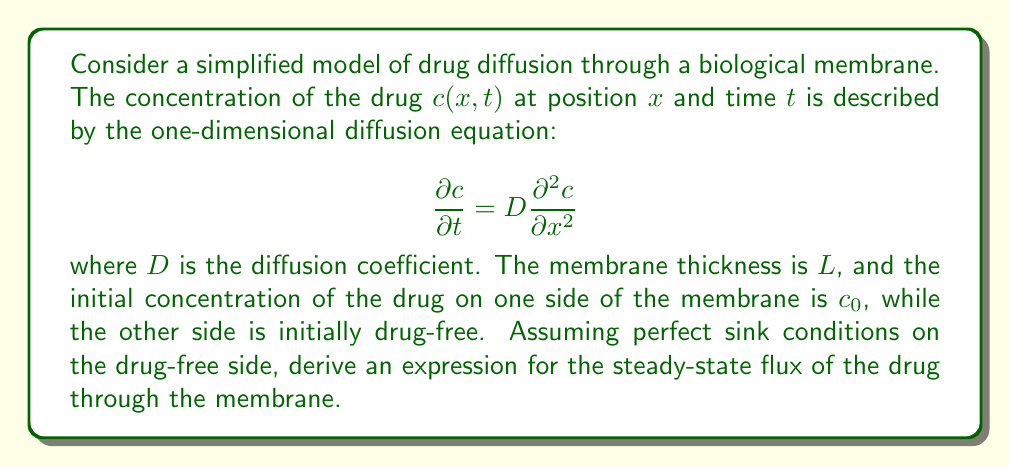Show me your answer to this math problem. To solve this problem, we'll follow these steps:

1) For steady-state conditions, the concentration doesn't change with time, so $\frac{\partial c}{\partial t} = 0$. The diffusion equation becomes:

   $$D \frac{\partial^2 c}{\partial x^2} = 0$$

2) Integrate this equation twice with respect to $x$:

   $$\frac{\partial c}{\partial x} = A$$
   $$c(x) = Ax + B$$

   where $A$ and $B$ are constants of integration.

3) Apply the boundary conditions:
   - At $x = 0$ (drug side): $c(0) = c_0$
   - At $x = L$ (sink side): $c(L) = 0$

4) Using these conditions:
   
   $c_0 = B$
   $0 = AL + c_0$

5) Solve for $A$:

   $$A = -\frac{c_0}{L}$$

6) The concentration profile is thus:

   $$c(x) = c_0(1 - \frac{x}{L})$$

7) The flux $J$ is given by Fick's first law:

   $$J = -D\frac{\partial c}{\partial x}$$

8) Differentiate the concentration profile:

   $$\frac{\partial c}{\partial x} = -\frac{c_0}{L}$$

9) Therefore, the steady-state flux is:

   $$J = D\frac{c_0}{L}$$

This is the expression for the steady-state flux of the drug through the membrane.
Answer: $J = D\frac{c_0}{L}$ 